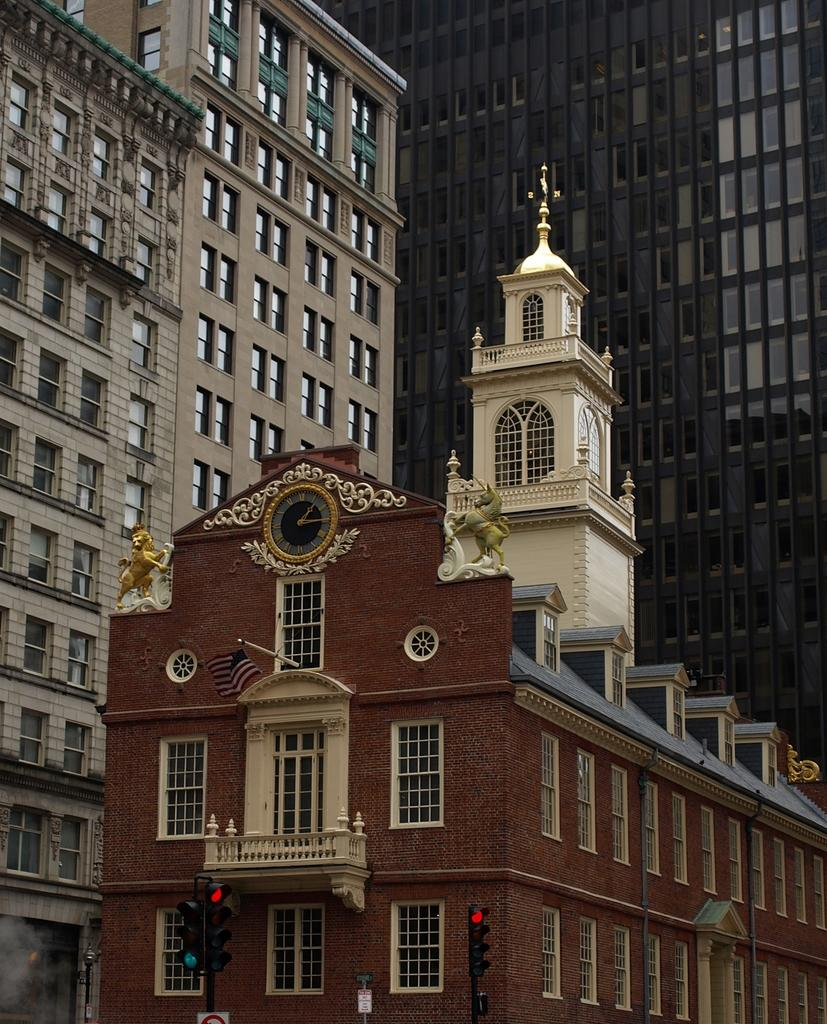What is located in the center of the image? There are buildings, a clock, statues, a pole, windows, and a balcony in the center of the image. Can you describe the clock in the center of the image? The clock is located in the center of the image. What is present at the bottom of the image? There are traffic lights, poles, and boards at the bottom of the image. What type of war is depicted in the image? There is no depiction of war in the image. How does the concept of time relate to the image? The presence of a clock in the image suggests the concept of time, but the image itself does not depict any specific time or time-related events. 